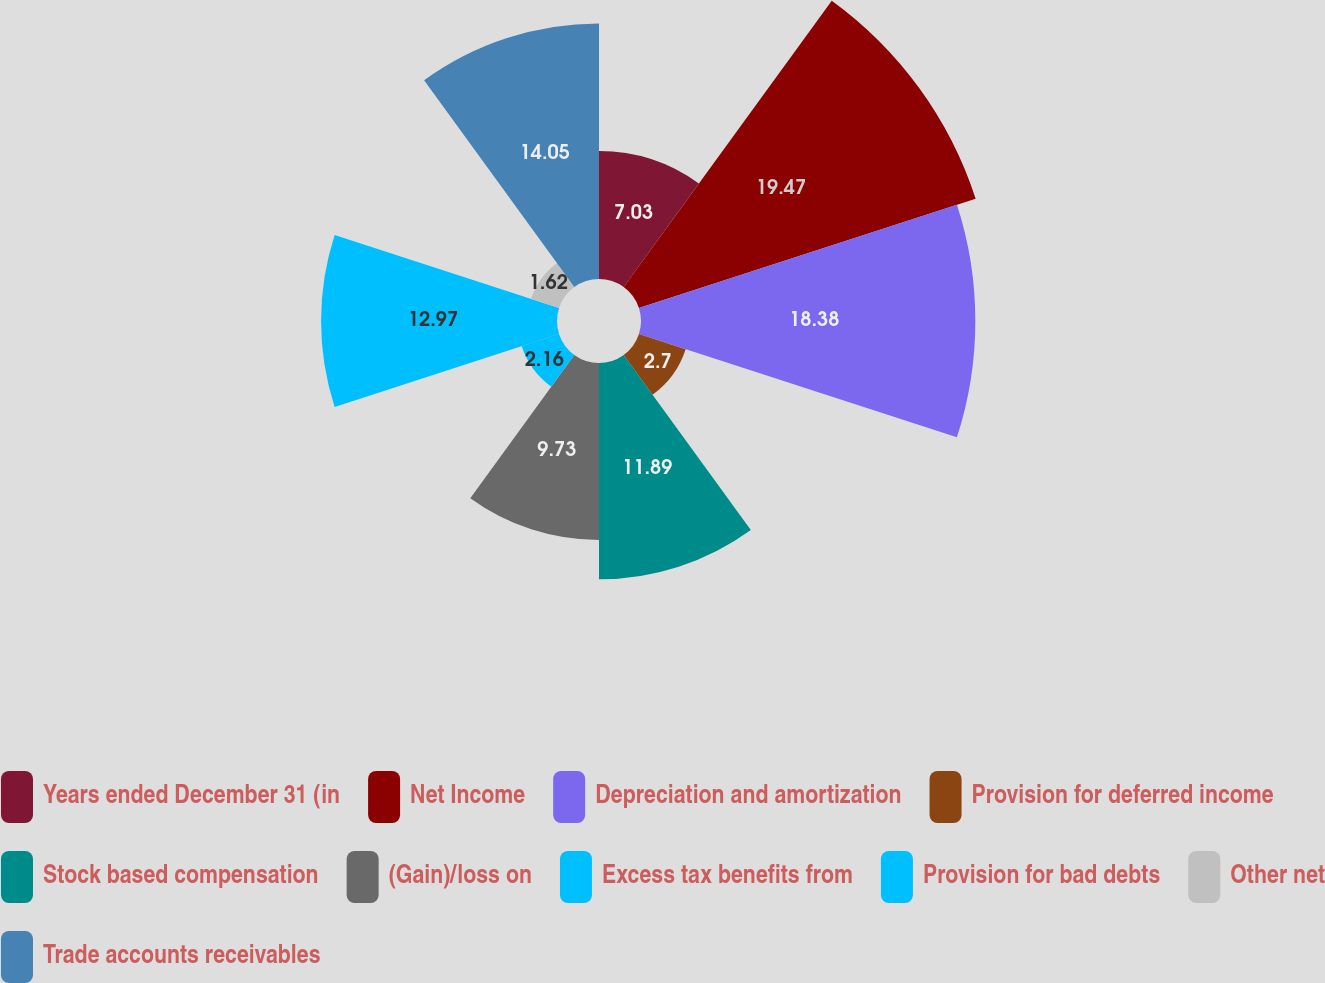Convert chart. <chart><loc_0><loc_0><loc_500><loc_500><pie_chart><fcel>Years ended December 31 (in<fcel>Net Income<fcel>Depreciation and amortization<fcel>Provision for deferred income<fcel>Stock based compensation<fcel>(Gain)/loss on<fcel>Excess tax benefits from<fcel>Provision for bad debts<fcel>Other net<fcel>Trade accounts receivables<nl><fcel>7.03%<fcel>19.46%<fcel>18.38%<fcel>2.7%<fcel>11.89%<fcel>9.73%<fcel>2.16%<fcel>12.97%<fcel>1.62%<fcel>14.05%<nl></chart> 